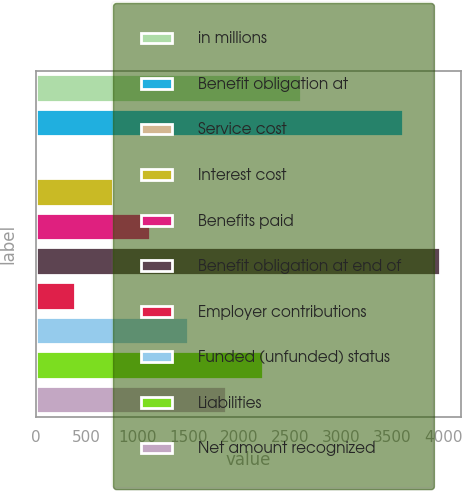Convert chart. <chart><loc_0><loc_0><loc_500><loc_500><bar_chart><fcel>in millions<fcel>Benefit obligation at<fcel>Service cost<fcel>Interest cost<fcel>Benefits paid<fcel>Benefit obligation at end of<fcel>Employer contributions<fcel>Funded (unfunded) status<fcel>Liabilities<fcel>Net amount recognized<nl><fcel>2602.8<fcel>3604<fcel>17<fcel>755.8<fcel>1125.2<fcel>3973.4<fcel>386.4<fcel>1494.6<fcel>2233.4<fcel>1864<nl></chart> 